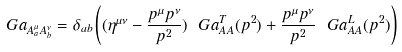Convert formula to latex. <formula><loc_0><loc_0><loc_500><loc_500>\ G a _ { A ^ { \mu } _ { a } A ^ { \nu } _ { b } } = \delta _ { a b } \left ( ( \eta ^ { \mu \nu } - \frac { p ^ { \mu } p ^ { \nu } } { p ^ { 2 } } ) \ G a ^ { T } _ { A A } ( p ^ { 2 } ) + \frac { p ^ { \mu } p ^ { \nu } } { p ^ { 2 } } \ G a ^ { L } _ { A A } ( p ^ { 2 } ) \right )</formula> 